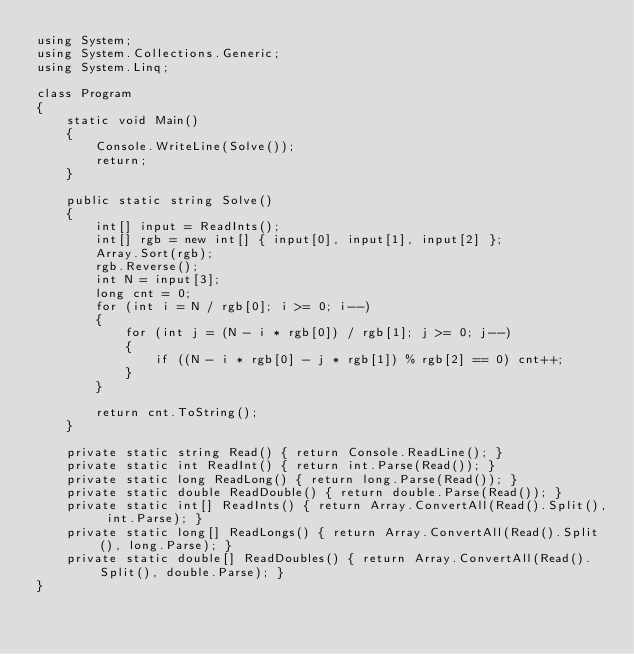<code> <loc_0><loc_0><loc_500><loc_500><_C#_>using System;
using System.Collections.Generic;
using System.Linq;

class Program
{
    static void Main()
    {
        Console.WriteLine(Solve());
        return;
    }

    public static string Solve()
    {
        int[] input = ReadInts();
        int[] rgb = new int[] { input[0], input[1], input[2] };
        Array.Sort(rgb);
        rgb.Reverse();
        int N = input[3];
        long cnt = 0;
        for (int i = N / rgb[0]; i >= 0; i--)
        {
            for (int j = (N - i * rgb[0]) / rgb[1]; j >= 0; j--)
            {
                if ((N - i * rgb[0] - j * rgb[1]) % rgb[2] == 0) cnt++;
            }
        }

        return cnt.ToString();
    }

    private static string Read() { return Console.ReadLine(); }
    private static int ReadInt() { return int.Parse(Read()); }
    private static long ReadLong() { return long.Parse(Read()); }
    private static double ReadDouble() { return double.Parse(Read()); }
    private static int[] ReadInts() { return Array.ConvertAll(Read().Split(), int.Parse); }
    private static long[] ReadLongs() { return Array.ConvertAll(Read().Split(), long.Parse); }
    private static double[] ReadDoubles() { return Array.ConvertAll(Read().Split(), double.Parse); }
}
</code> 